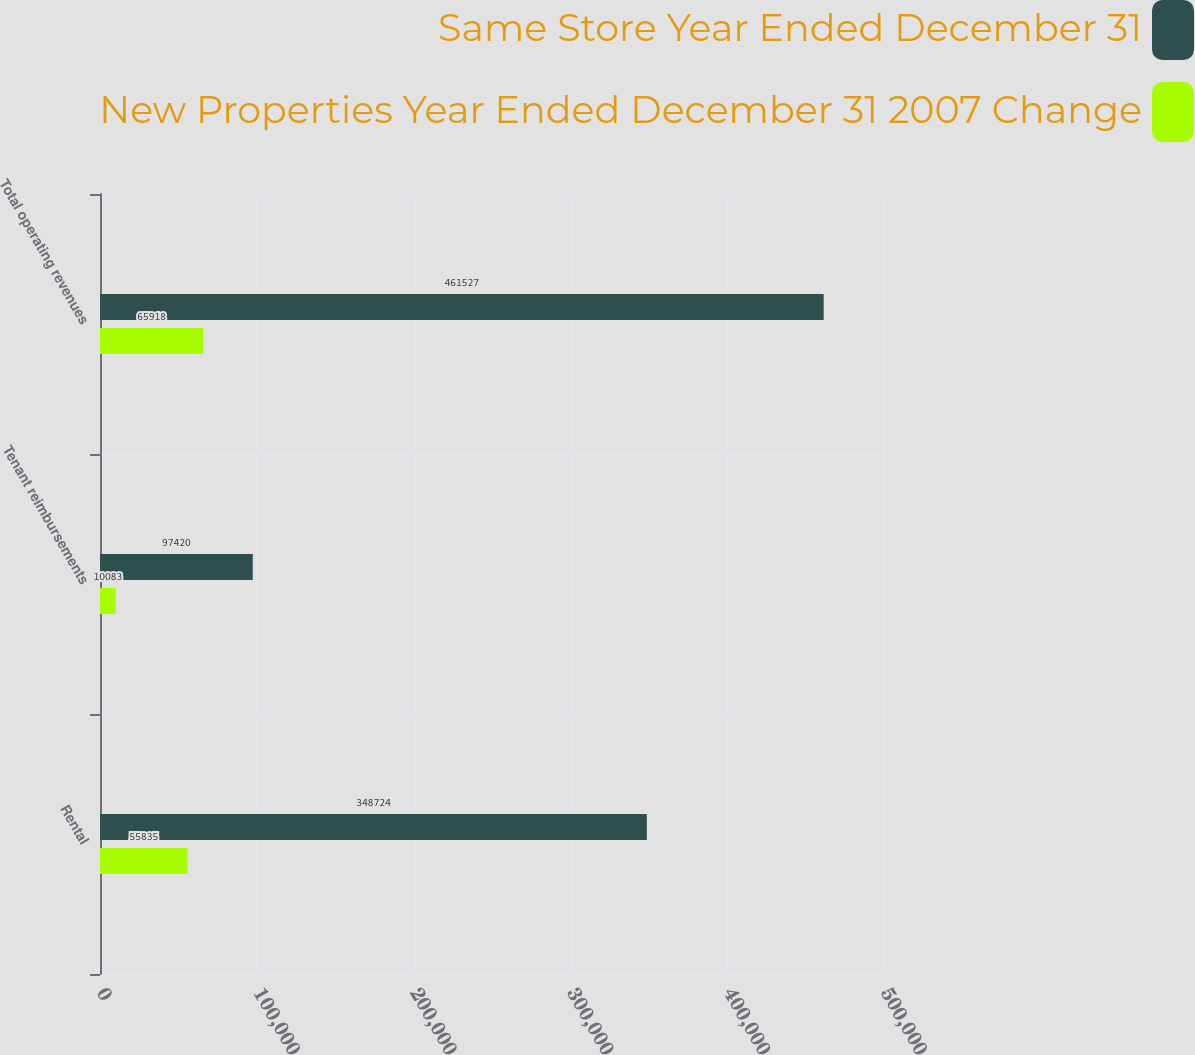Convert chart. <chart><loc_0><loc_0><loc_500><loc_500><stacked_bar_chart><ecel><fcel>Rental<fcel>Tenant reimbursements<fcel>Total operating revenues<nl><fcel>Same Store Year Ended December 31<fcel>348724<fcel>97420<fcel>461527<nl><fcel>New Properties Year Ended December 31 2007 Change<fcel>55835<fcel>10083<fcel>65918<nl></chart> 